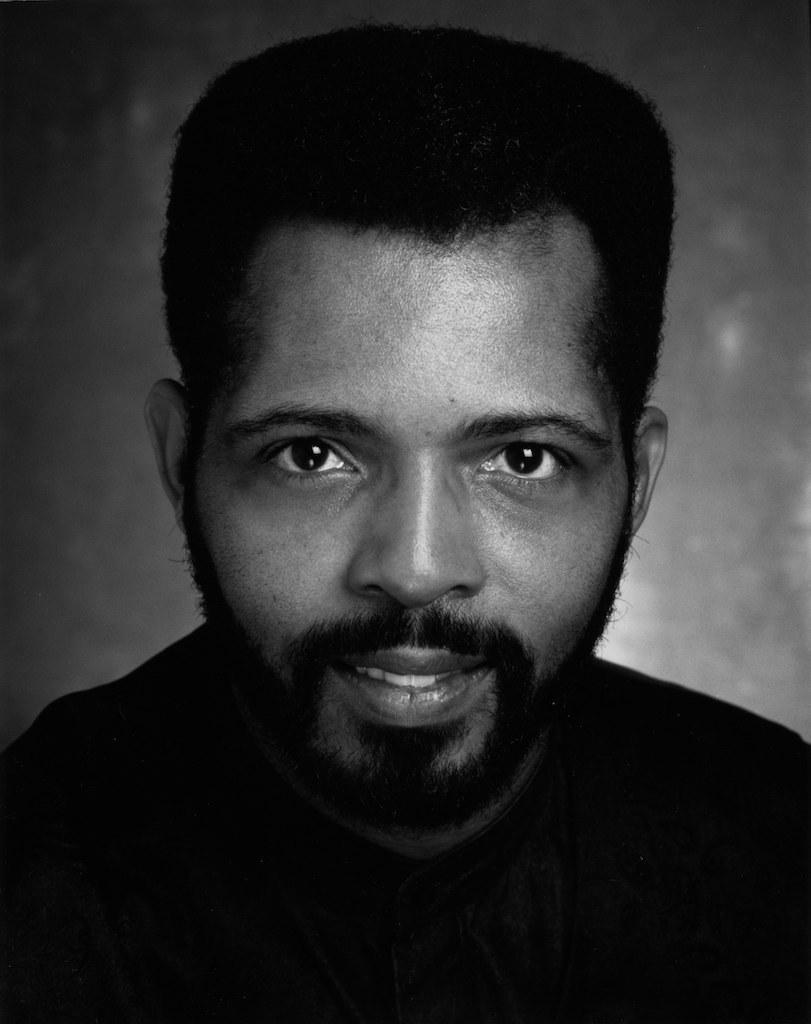Can you describe this image briefly? In this image I can see a person and the image is in black and white. 